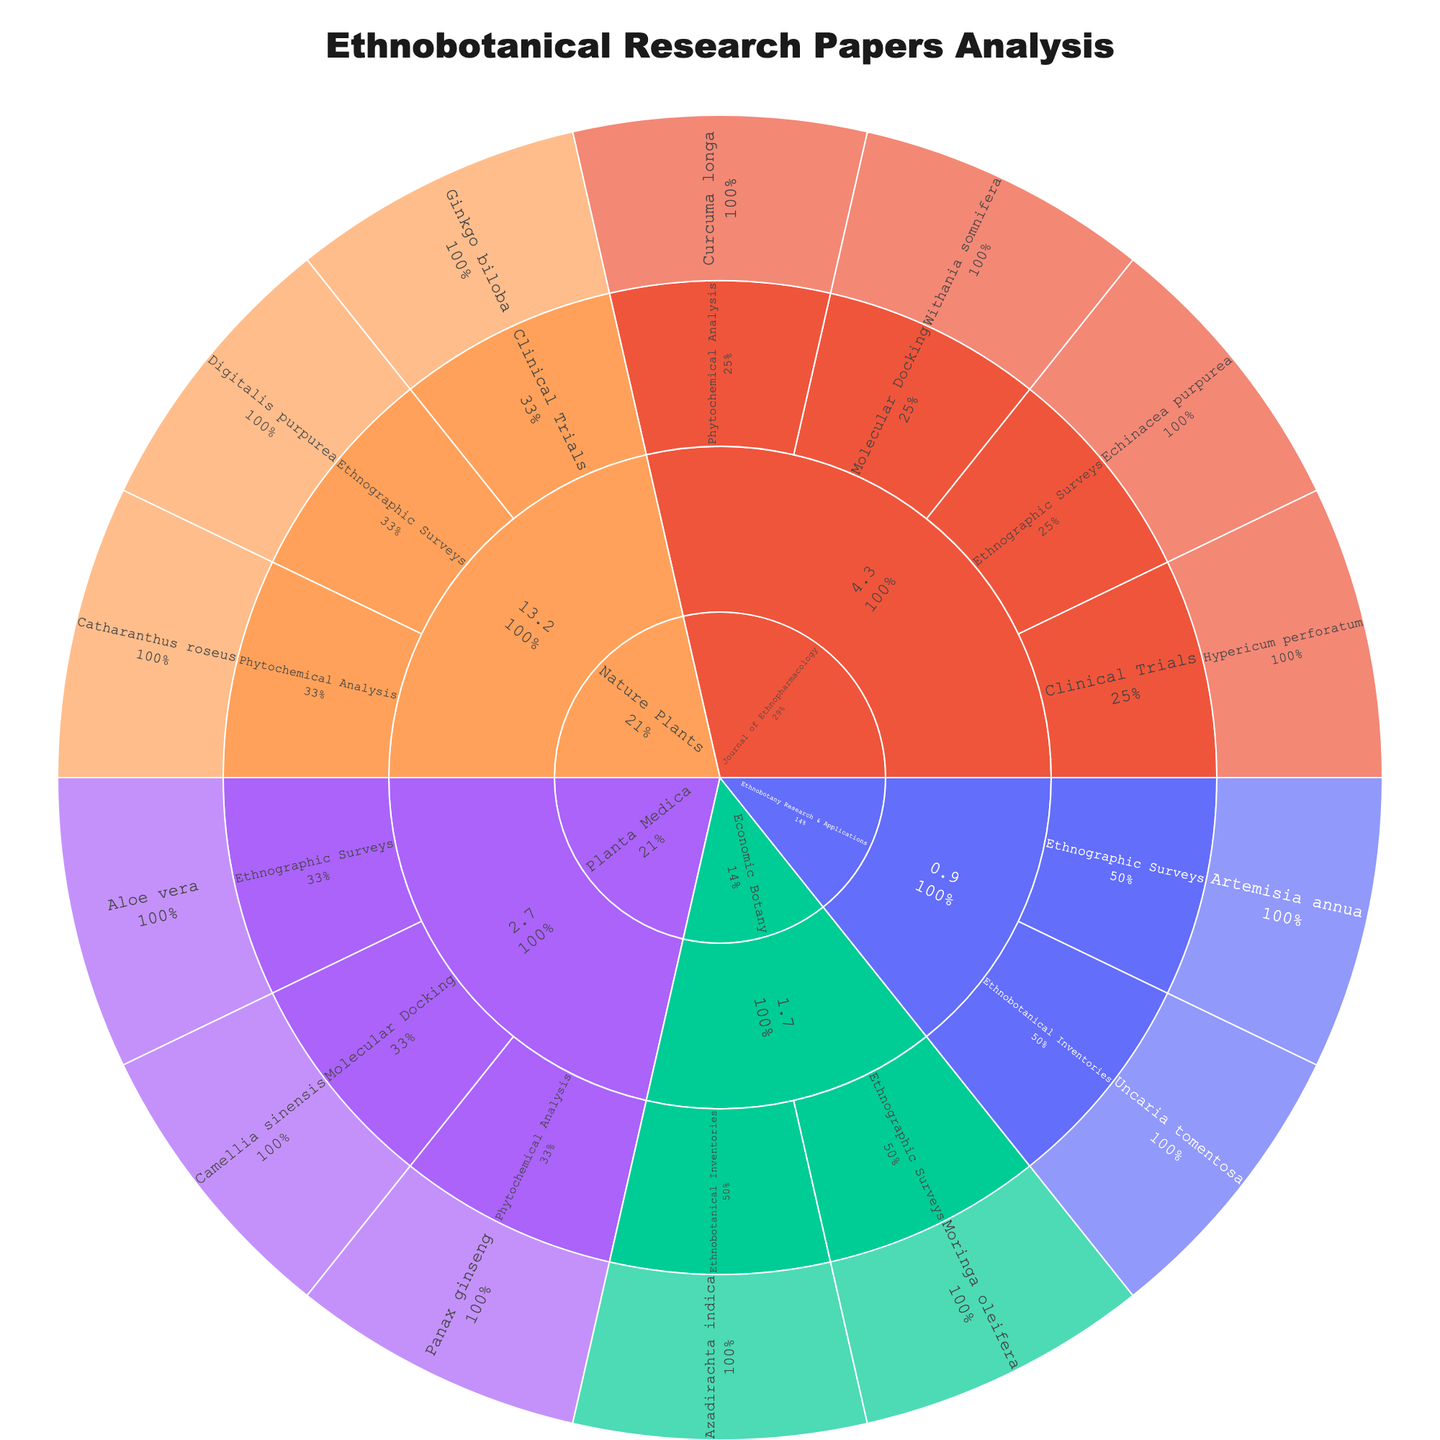What's the title of the sunburst plot? The title of the sunburst plot is a large text usually centered at the top of the figure. It typically provides an overview of what the plot represents in a concise format.
Answer: Ethnobotanical Research Papers Analysis Which journal has the highest impact factor in this study? Identify the categories of journals listed and find the one with the highest numerical value.
Answer: Nature Plants How many research methodologies are studied in 'Planta Medica'? Locate the section for 'Planta Medica' within the sunburst plot, then count the distinct research methodologies shown beneath it.
Answer: Three (Ethnographic Surveys, Phytochemical Analysis, Molecular Docking) Which plant species is associated with clinical trials in 'Journal of Ethnopharmacology'? Locate the 'Journal of Ethnopharmacology' section, find the subcategory 'Clinical Trials,' and identify the associated plant species.
Answer: Hypericum perforatum Compare the number of plant species studied under 'Ethnobotany Research & Applications' and 'Economic Botany'. Which journal has more variety? Count the distinct plant species displayed under the sections of 'Ethnobotany Research & Applications' and 'Economic Botany' and compare.
Answer: Economic Botany What percentage of studies in 'Nature Plants' use ethnographic surveys as a research methodology? Locate 'Nature Plants' and identify the 'Ethnographic Surveys' section. Refer to the accompanying percentage that indicates its proportion within the parent group.
Answer: Approximately 33.33% How many plant species are studied using Phytochemical Analysis across all journals? Look through the entire sunburst plot and count the plant species listed under the 'Phytochemical Analysis' methodology.
Answer: Three (Catharanthus roseus, Curcuma longa, Panax ginseng) Identify the plant species associated with Ethnographic Surveys with the lowest journal impact factor. Find the Ethnographic Surveys category across different journals, then identify the journal with the lowest impact factor and list the associated plant species.
Answer: Artemisia annua 